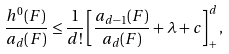Convert formula to latex. <formula><loc_0><loc_0><loc_500><loc_500>\frac { h ^ { 0 } ( F ) } { a _ { d } ( F ) } \leq \frac { 1 } { d ! } \left [ \frac { a _ { d - 1 } ( F ) } { a _ { d } ( F ) } + \lambda + c \right ] _ { + } ^ { d } ,</formula> 